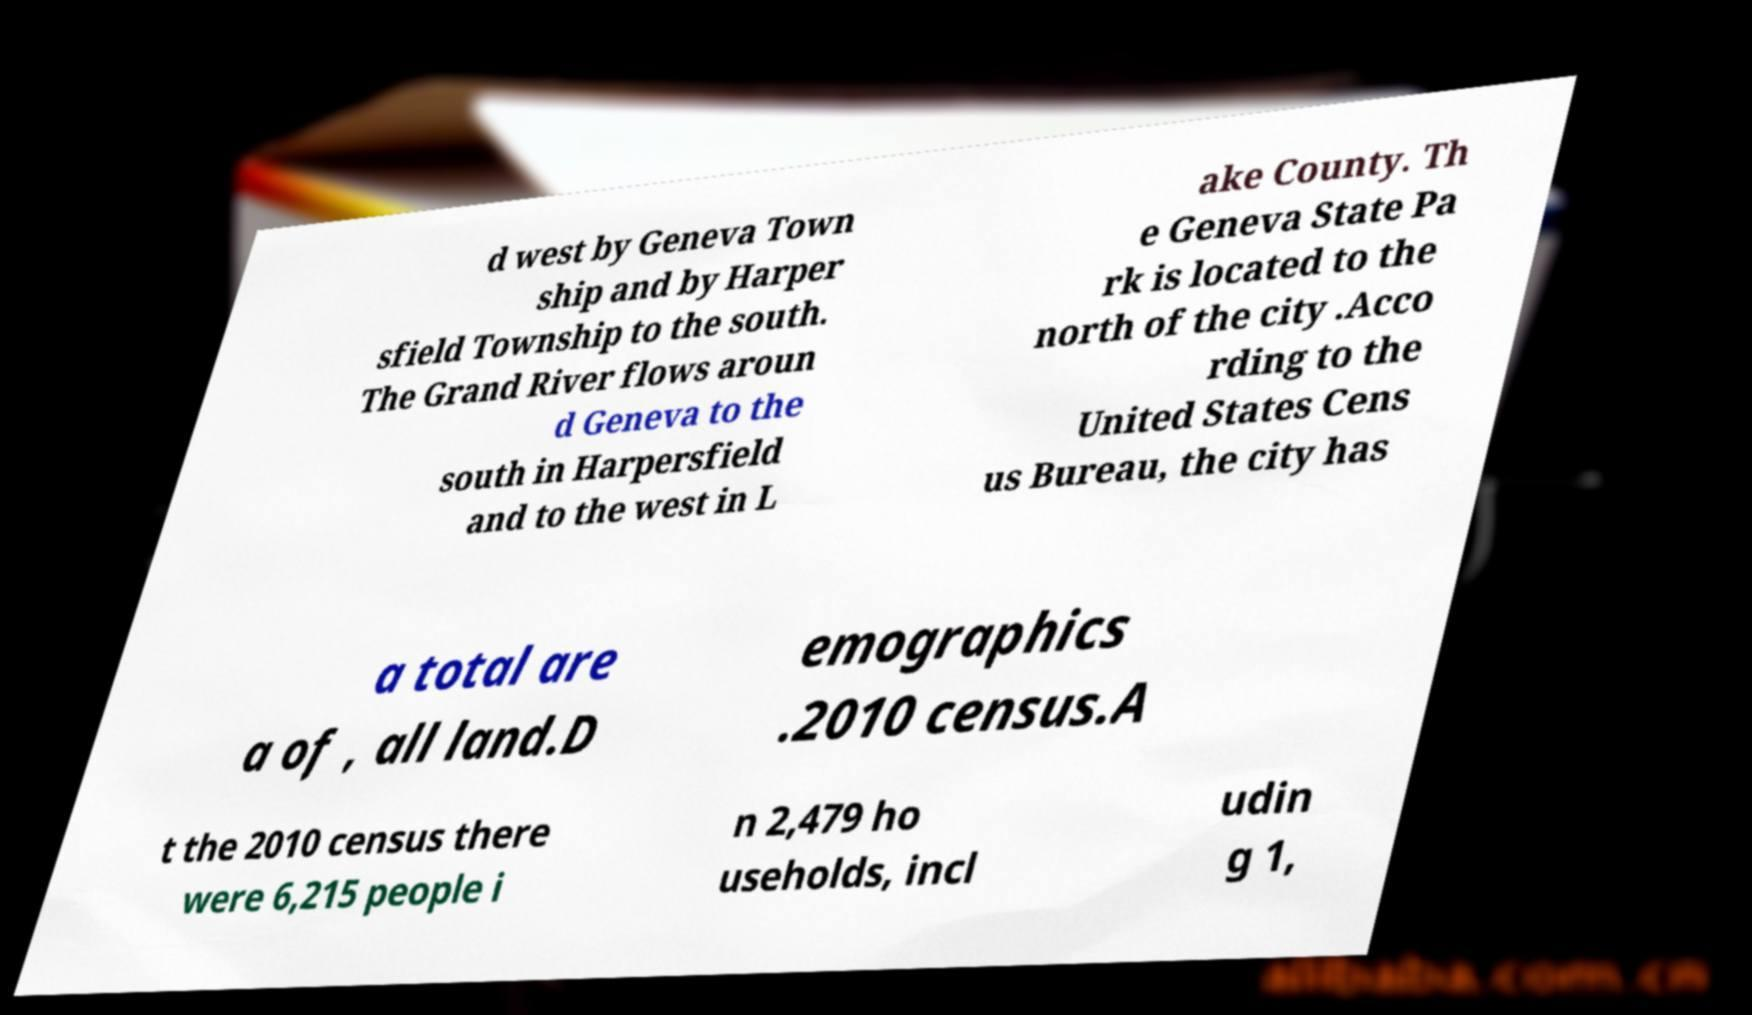I need the written content from this picture converted into text. Can you do that? d west by Geneva Town ship and by Harper sfield Township to the south. The Grand River flows aroun d Geneva to the south in Harpersfield and to the west in L ake County. Th e Geneva State Pa rk is located to the north of the city .Acco rding to the United States Cens us Bureau, the city has a total are a of , all land.D emographics .2010 census.A t the 2010 census there were 6,215 people i n 2,479 ho useholds, incl udin g 1, 